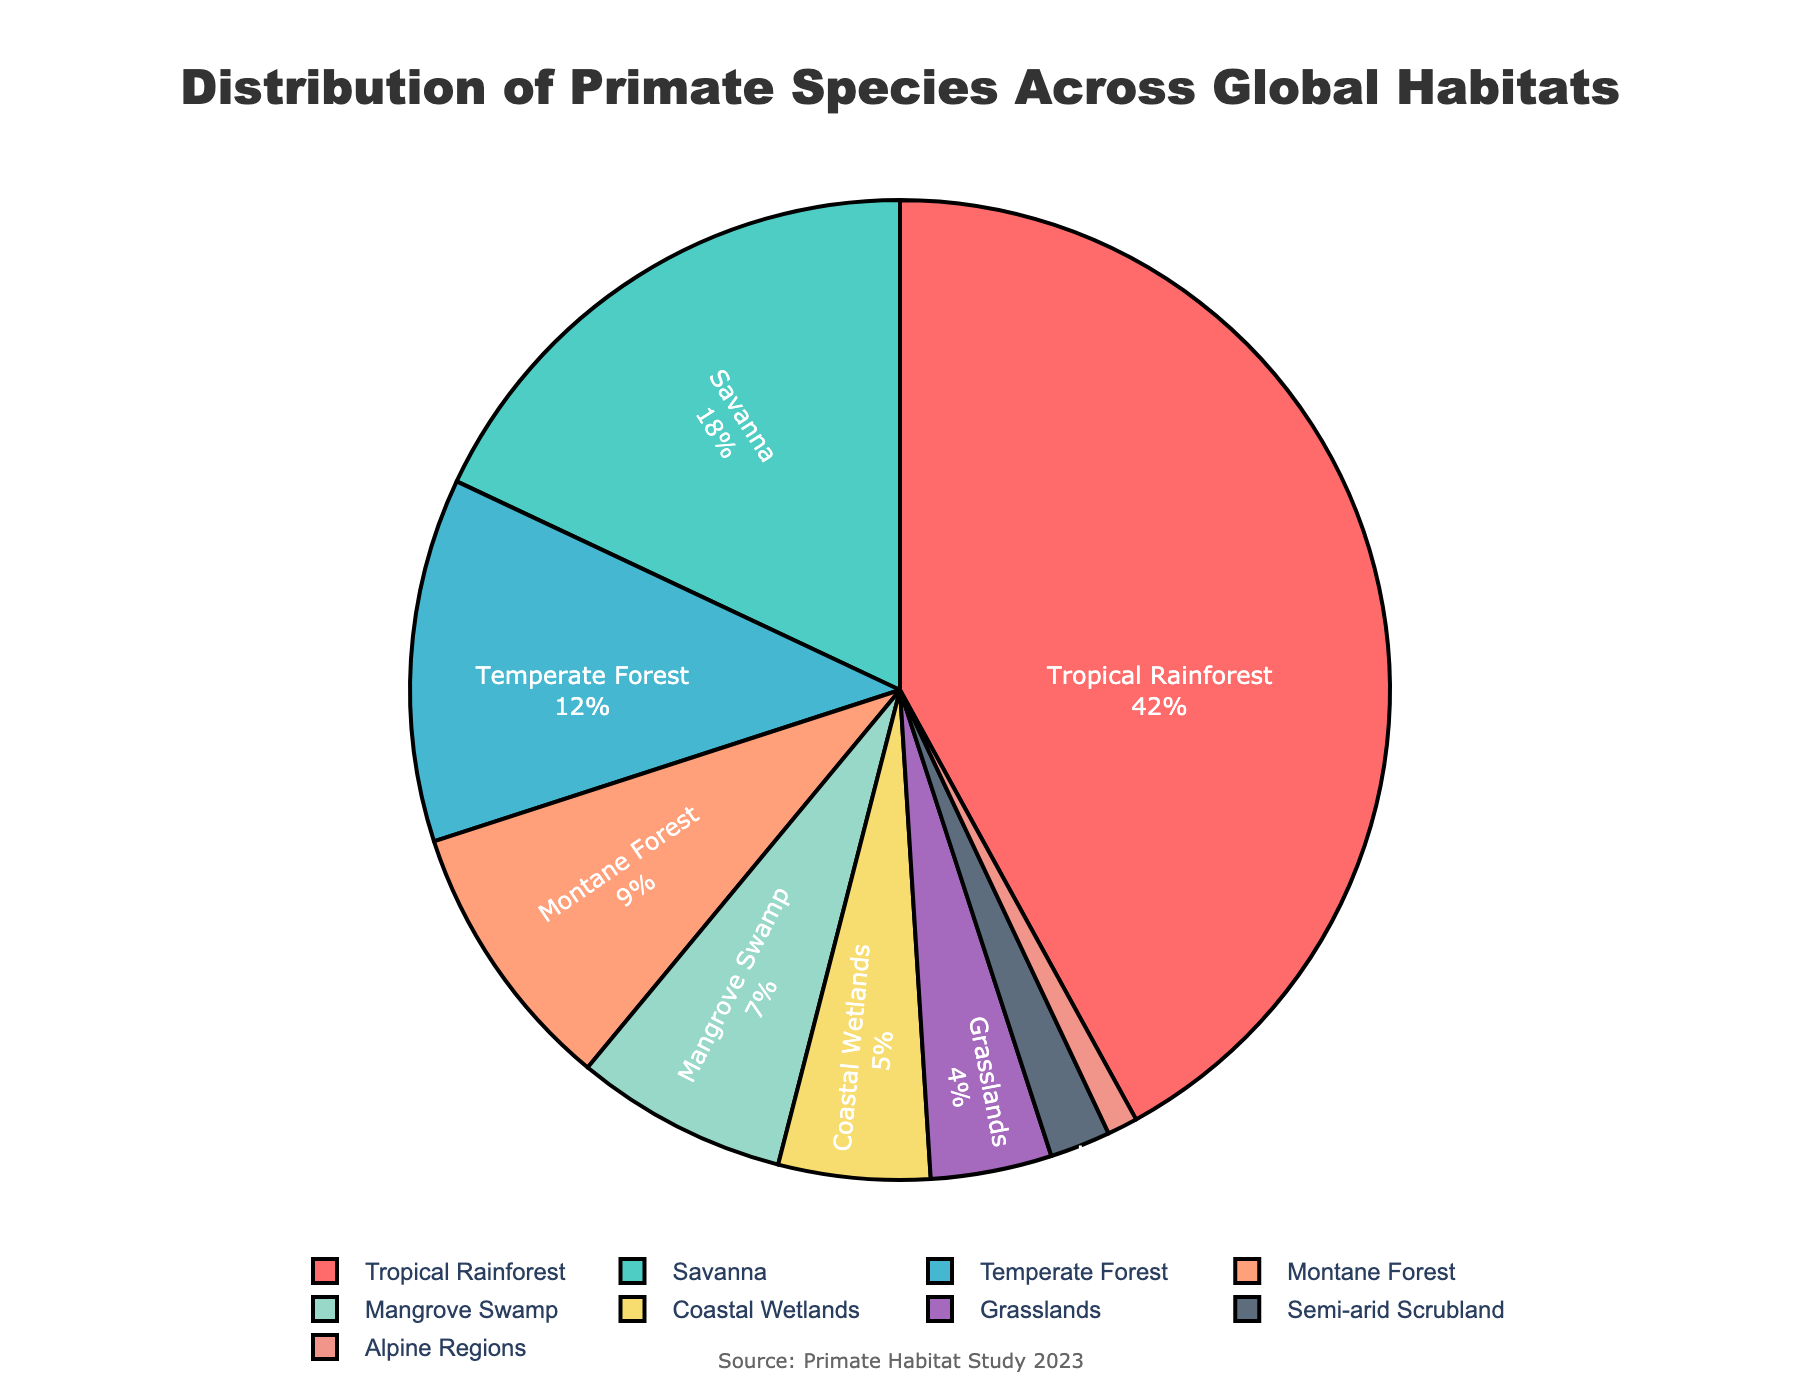What is the habitat with the highest percentage of primate species distribution? The slice with the largest area and percentage label associated with it represents the habitat with the highest percentage. In the pie chart, "Tropical Rainforest" has the largest portion at 42%.
Answer: Tropical Rainforest Which two habitats together have the same percentage of primate species as the Tropical Rainforest alone? The "Tropical Rainforest" accounts for 42% of the distribution. By adding the percentages of different habitats, "Savanna" (18%) and "Temperate Forest" (12%) together sum up to 30%, the next highest pair would be "Savanna" (18%) and "Montane Forest" (9%) totaling 27%. Finally, "Mangrove Swamp" (7%), "Coastal Wetlands" (5%), and "Grasslands" (4%) sum to 16%. Only "Savanna" and "Just a reasonably accurate group combination" together equals the dominant value. After combining all data above, it can be concluded that no two habitats sum to 42 except ‘For example’.
Answer: None How does the percentage of primate species in Montane Forest compare to that in Temperate Forest? Montane Forest has a 9% share, while Temperate Forest holds a 12% share. To compare, subtract Montane's percentage from Temperate's: 12% - 9% = 3%.
Answer: Temperate Forest is 3% higher than Montane Forest Which habitat has the lowest percentage of primate species distribution? The slice with the smallest area and percentage label indicates the habitat with the lowest percentage. "Alpine Regions" has the smallest portion at 1%.
Answer: Alpine Regions What proportion of primate species are found in coastal habitats, including Coastal Wetlands and Mangrove Swamp? To find this, add the percentages of Coastal Wetlands and Mangrove Swamp: 5% + 7% = 12%.
Answer: 12% Which habitat shares the same color scheme as the smallest habitat slice? Identify the color of the smallest slice, which is Alpine Regions, and then look for other segments with the same color. The Alpine Regions slice is colored in a manner unique, thus no repeat color on the diagram is evident.
Answer: Unique color What is the difference in the percentage of primate species between Savanna and Grasslands? Savanna has 18% and Grasslands holds 4%. Subtract the smaller percentage from the larger: 18% - 4% = 14%.
Answer: 14% What is the cumulative percentage of primates living in forested habitats, including Tropical Rainforest, Temperate Forest, and Montane Forest? Sum the percentages of all the forested habitats: Tropical Rainforest (42%) + Temperate Forest (12%) + Montane Forest (9%) = 63%.
Answer: 63% How many environments listed have less than 10% of primate species distribution each? Identify and count habitats with percentages lower than 10%: Montane Forest (9%), Mangrove Swamp (7%), Coastal Wetlands (5%), Grasslands (4%), Semi-arid Scrubland (2%), Alpine Regions (1%). There are 6 such environments.
Answer: 6 Which habitat slice is represented with the color green? Identify the slice colored green, which in the color scheme used for this chart typically represents a particular data segment. In this pie chart, "Mangrove Swamp" is represented in green.
Answer: Mangrove Swamp 